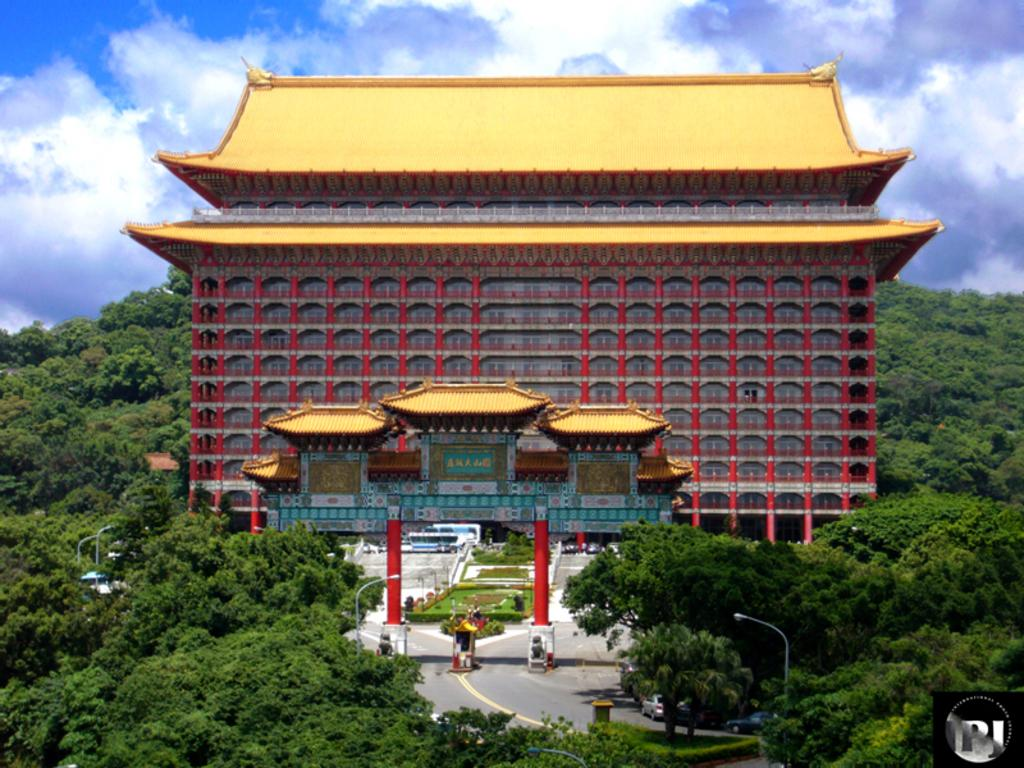What type of natural elements can be seen in the image? There are trees in the image. What man-made structure is visible in the image? There is a road and a building in the image. Can you describe the building in the background? The building is yellow and red in color. What else can be seen in the background of the image? There are trees in the background of the image. What is visible at the top of the image? The sky is visible at the top of the image and is clear. What type of yoke is used to carry the tub in the image? There is no yoke or tub present in the image. How many gallons of paint are visible in the image? There is no paint present in the image. 